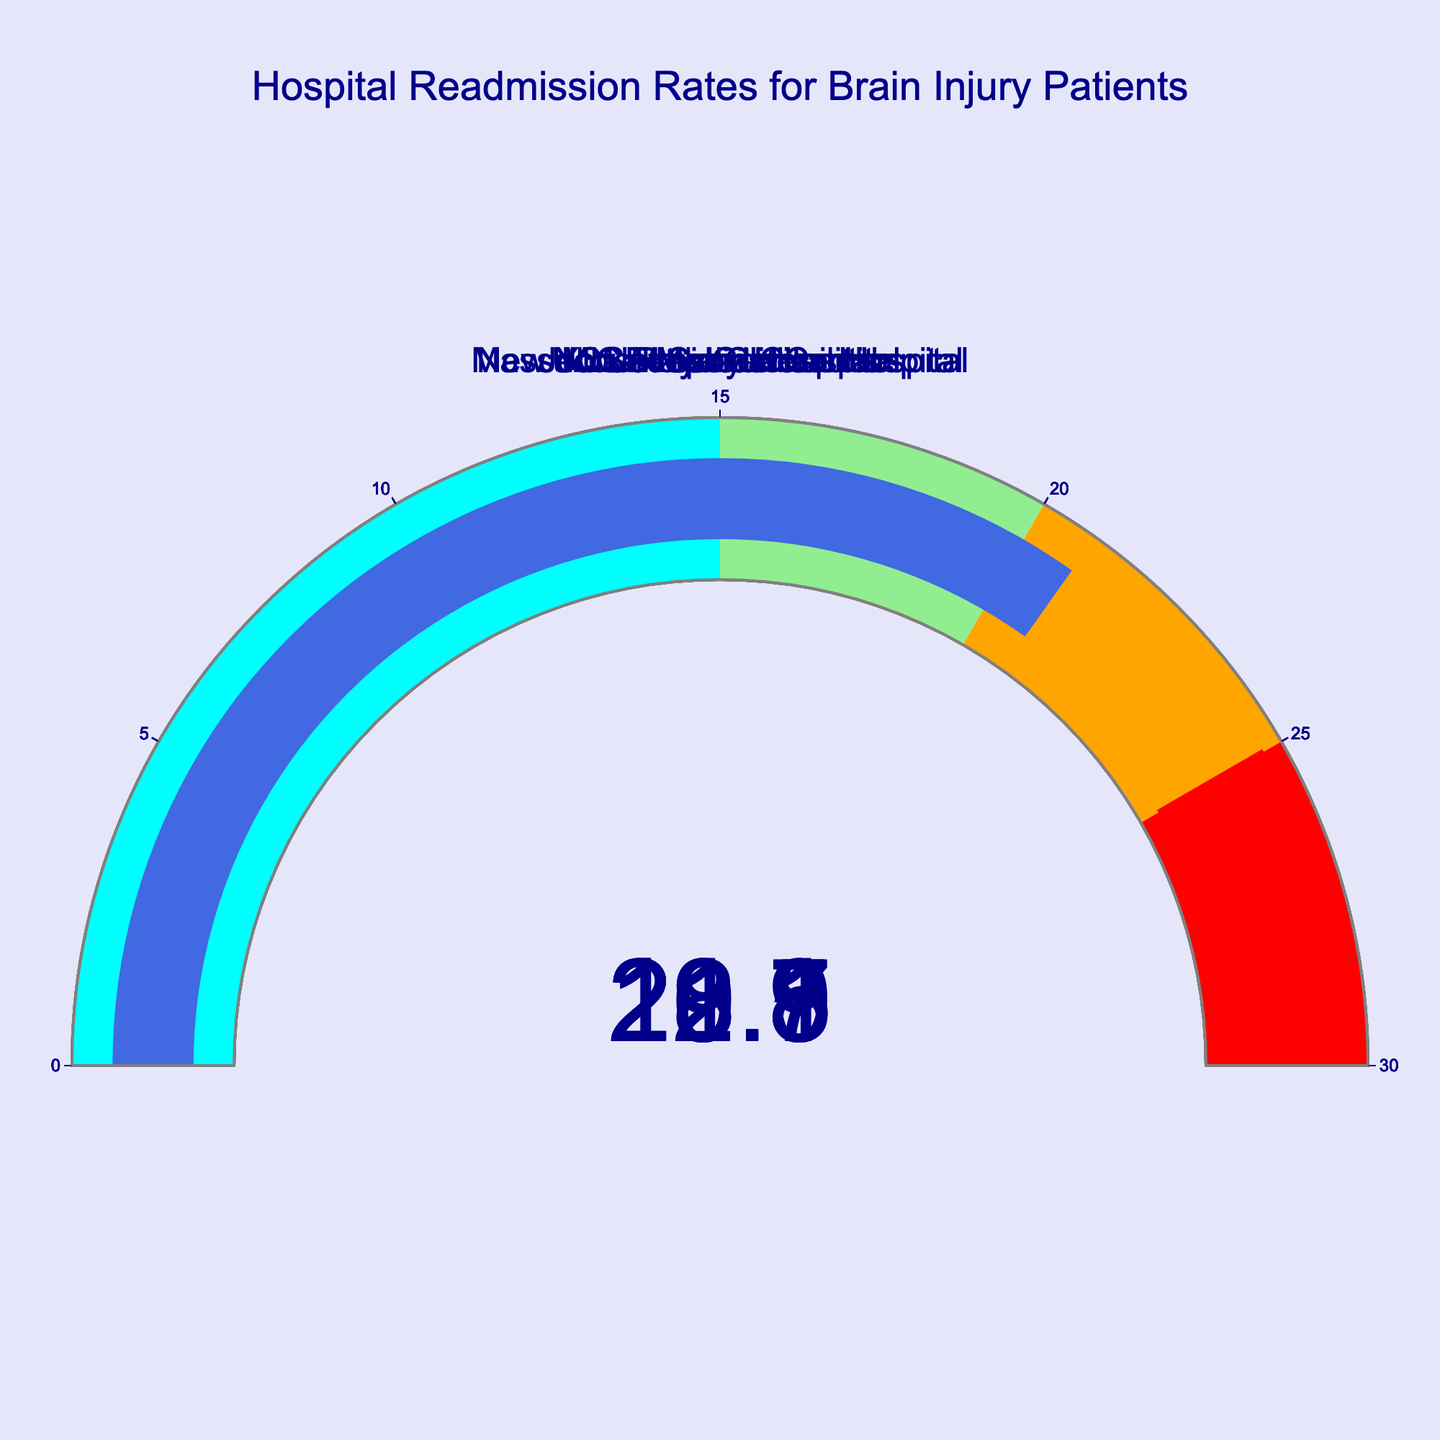What is the title of the figure? The title is located at the top of the figure. It states "Hospital Readmission Rates for Brain Injury Patients"
Answer: Hospital Readmission Rates for Brain Injury Patients How many hospitals are displayed in the figure? By counting the number of gauge charts, there are 7 hospitals shown
Answer: 7 What color represents the readmission rate range of 20 to 25 on the gauge? The gauge steps are color-coded, and the range from 20 to 25 is represented by the color orange
Answer: orange What's the highest readmission rate displayed? The gauges show the readmission rates for each hospital. The highest value is 23.1 at New York-Presbyterian Hospital
Answer: 23.1 What's the threshold value set on the gauge? The threshold is indicated by a red line on the gauge chart. The value is set at 25
Answer: 25 What is the average readmission rate of all the hospitals? Sum all the readmission rates (18.5+22.3+20.7+19.8+21.5+23.1+20.9) and divide by the number of hospitals (7) to find the average: (147.9/7)
Answer: 21.13 What is the difference in readmission rates between Johns Hopkins Hospital and Cleveland Clinic? Subtract Cleveland Clinic's readmission rate (20.7) from Johns Hopkins Hospital's rate (22.3): 22.3 - 20.7
Answer: 1.6 What is the total readmission rate for Mayo Clinic and New York-Presbyterian Hospital combined? Add the readmission rates of Mayo Clinic (18.5) and New York-Presbyterian Hospital (23.1): 18.5 + 23.1
Answer: 41.6 Which hospital has the lowest readmission rate? Examine each gauge and find the smallest readmission value. Mayo Clinic has the lowest rate at 18.5
Answer: Mayo Clinic Is Massachusetts General Hospital's readmission rate greater than or equal to UCSF Medical Center's? Compare Massachusetts General Hospital's rate (19.8) to UCSF Medical Center's rate (21.5). 19.8 is less than 21.5
Answer: No Which is higher, the readmission rate for Mount Sinai Hospital or Cleveland Clinic? Compare Mount Sinai Hospital's rate (20.9) with Cleveland Clinic's rate (20.7). 20.9 is higher than 20.7
Answer: Mount Sinai Hospital Which hospitals fall into the orange range (20 to 25) on the gauge? The orange range on the gauge represents readmission rates between 20 and 25. The hospitals in this range are Cleveland Clinic, UCSF Medical Center, New York-Presbyterian Hospital, and Mount Sinai Hospital
Answer: Cleveland Clinic, UCSF Medical Center, New York-Presbyterian Hospital, Mount Sinai Hospital How many hospitals have a readmission rate above the green range (> 20)? Count the number of hospitals with readmission rates over 20, which is the green range. These are Johns Hopkins Hospital, Cleveland Clinic, UCSF Medical Center, New York-Presbyterian Hospital, and Mount Sinai Hospital. There are 5 in total
Answer: 5 